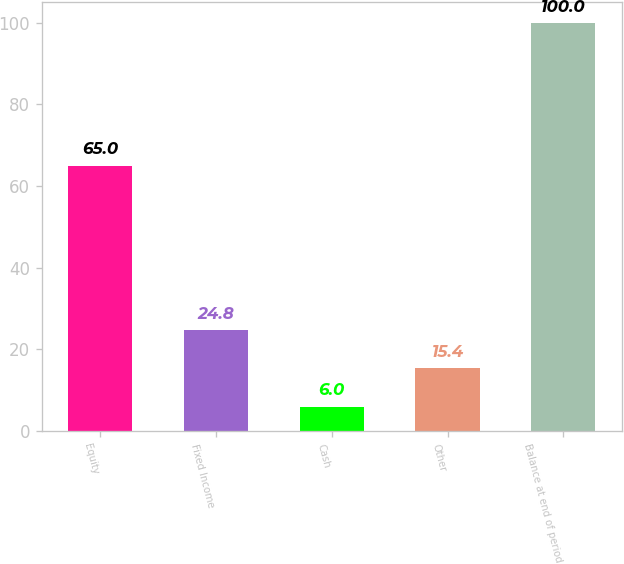Convert chart. <chart><loc_0><loc_0><loc_500><loc_500><bar_chart><fcel>Equity<fcel>Fixed Income<fcel>Cash<fcel>Other<fcel>Balance at end of period<nl><fcel>65<fcel>24.8<fcel>6<fcel>15.4<fcel>100<nl></chart> 